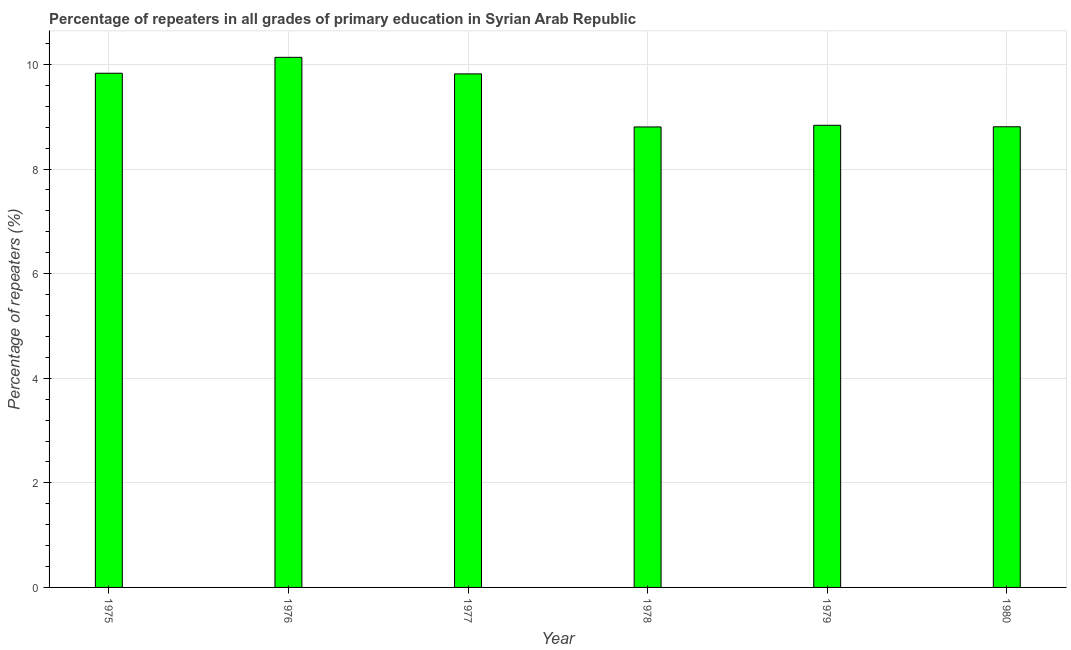Does the graph contain any zero values?
Offer a very short reply. No. What is the title of the graph?
Offer a very short reply. Percentage of repeaters in all grades of primary education in Syrian Arab Republic. What is the label or title of the Y-axis?
Give a very brief answer. Percentage of repeaters (%). What is the percentage of repeaters in primary education in 1980?
Offer a terse response. 8.81. Across all years, what is the maximum percentage of repeaters in primary education?
Provide a succinct answer. 10.14. Across all years, what is the minimum percentage of repeaters in primary education?
Your answer should be compact. 8.81. In which year was the percentage of repeaters in primary education maximum?
Provide a succinct answer. 1976. In which year was the percentage of repeaters in primary education minimum?
Offer a very short reply. 1978. What is the sum of the percentage of repeaters in primary education?
Offer a very short reply. 56.24. What is the difference between the percentage of repeaters in primary education in 1976 and 1977?
Ensure brevity in your answer.  0.32. What is the average percentage of repeaters in primary education per year?
Your response must be concise. 9.37. What is the median percentage of repeaters in primary education?
Give a very brief answer. 9.33. Do a majority of the years between 1979 and 1978 (inclusive) have percentage of repeaters in primary education greater than 4.4 %?
Your answer should be very brief. No. What is the ratio of the percentage of repeaters in primary education in 1977 to that in 1979?
Your response must be concise. 1.11. Is the difference between the percentage of repeaters in primary education in 1975 and 1980 greater than the difference between any two years?
Make the answer very short. No. What is the difference between the highest and the second highest percentage of repeaters in primary education?
Offer a very short reply. 0.3. What is the difference between the highest and the lowest percentage of repeaters in primary education?
Your response must be concise. 1.33. How many bars are there?
Your answer should be very brief. 6. Are the values on the major ticks of Y-axis written in scientific E-notation?
Keep it short and to the point. No. What is the Percentage of repeaters (%) in 1975?
Offer a terse response. 9.83. What is the Percentage of repeaters (%) in 1976?
Your answer should be very brief. 10.14. What is the Percentage of repeaters (%) of 1977?
Your answer should be very brief. 9.82. What is the Percentage of repeaters (%) of 1978?
Provide a short and direct response. 8.81. What is the Percentage of repeaters (%) of 1979?
Your answer should be compact. 8.84. What is the Percentage of repeaters (%) of 1980?
Provide a short and direct response. 8.81. What is the difference between the Percentage of repeaters (%) in 1975 and 1976?
Provide a short and direct response. -0.3. What is the difference between the Percentage of repeaters (%) in 1975 and 1977?
Your answer should be compact. 0.01. What is the difference between the Percentage of repeaters (%) in 1975 and 1978?
Your response must be concise. 1.03. What is the difference between the Percentage of repeaters (%) in 1975 and 1979?
Your response must be concise. 1. What is the difference between the Percentage of repeaters (%) in 1975 and 1980?
Your answer should be compact. 1.02. What is the difference between the Percentage of repeaters (%) in 1976 and 1977?
Ensure brevity in your answer.  0.32. What is the difference between the Percentage of repeaters (%) in 1976 and 1978?
Your answer should be compact. 1.33. What is the difference between the Percentage of repeaters (%) in 1976 and 1979?
Your answer should be compact. 1.3. What is the difference between the Percentage of repeaters (%) in 1976 and 1980?
Your response must be concise. 1.33. What is the difference between the Percentage of repeaters (%) in 1977 and 1978?
Make the answer very short. 1.01. What is the difference between the Percentage of repeaters (%) in 1977 and 1979?
Keep it short and to the point. 0.98. What is the difference between the Percentage of repeaters (%) in 1977 and 1980?
Your answer should be very brief. 1.01. What is the difference between the Percentage of repeaters (%) in 1978 and 1979?
Your response must be concise. -0.03. What is the difference between the Percentage of repeaters (%) in 1978 and 1980?
Make the answer very short. -0. What is the difference between the Percentage of repeaters (%) in 1979 and 1980?
Ensure brevity in your answer.  0.03. What is the ratio of the Percentage of repeaters (%) in 1975 to that in 1976?
Make the answer very short. 0.97. What is the ratio of the Percentage of repeaters (%) in 1975 to that in 1978?
Provide a short and direct response. 1.12. What is the ratio of the Percentage of repeaters (%) in 1975 to that in 1979?
Ensure brevity in your answer.  1.11. What is the ratio of the Percentage of repeaters (%) in 1975 to that in 1980?
Give a very brief answer. 1.12. What is the ratio of the Percentage of repeaters (%) in 1976 to that in 1977?
Your answer should be compact. 1.03. What is the ratio of the Percentage of repeaters (%) in 1976 to that in 1978?
Give a very brief answer. 1.15. What is the ratio of the Percentage of repeaters (%) in 1976 to that in 1979?
Keep it short and to the point. 1.15. What is the ratio of the Percentage of repeaters (%) in 1976 to that in 1980?
Offer a very short reply. 1.15. What is the ratio of the Percentage of repeaters (%) in 1977 to that in 1978?
Keep it short and to the point. 1.11. What is the ratio of the Percentage of repeaters (%) in 1977 to that in 1979?
Your answer should be compact. 1.11. What is the ratio of the Percentage of repeaters (%) in 1977 to that in 1980?
Your answer should be very brief. 1.11. What is the ratio of the Percentage of repeaters (%) in 1978 to that in 1979?
Make the answer very short. 1. What is the ratio of the Percentage of repeaters (%) in 1978 to that in 1980?
Your response must be concise. 1. What is the ratio of the Percentage of repeaters (%) in 1979 to that in 1980?
Provide a succinct answer. 1. 